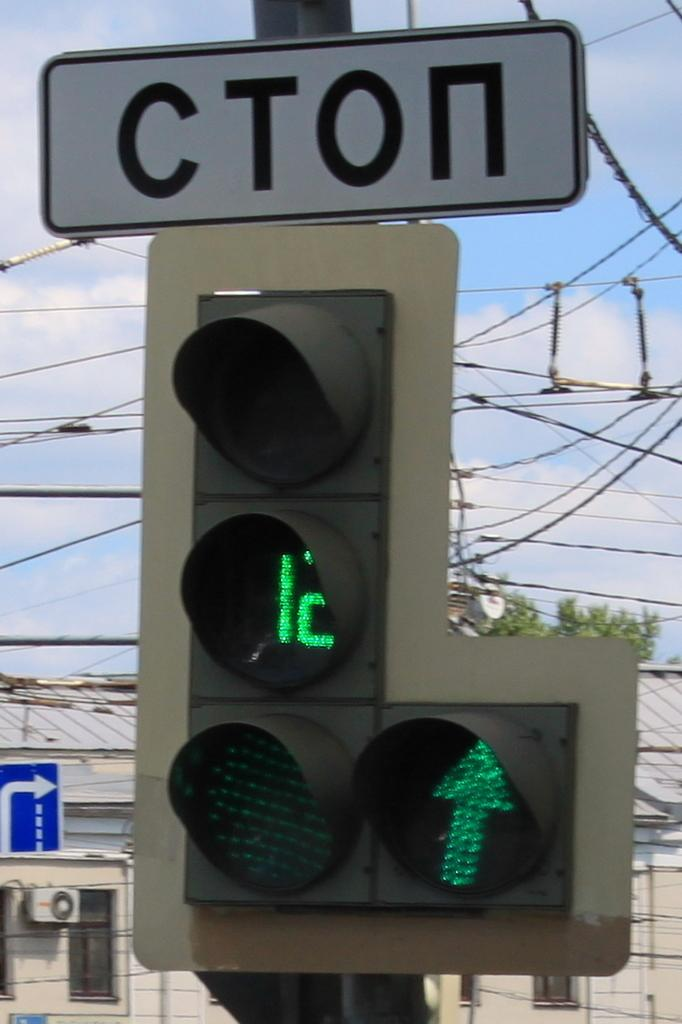<image>
Relay a brief, clear account of the picture shown. a Cyrillic sign reads CTON by a traffic light 